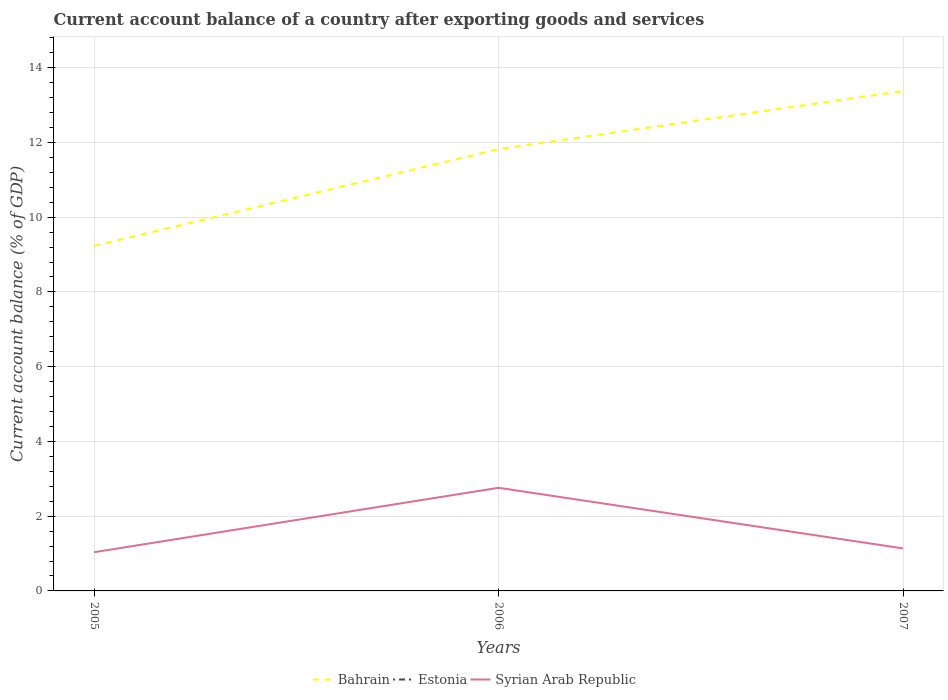Does the line corresponding to Syrian Arab Republic intersect with the line corresponding to Estonia?
Offer a very short reply. No. Is the number of lines equal to the number of legend labels?
Your response must be concise. No. Across all years, what is the maximum account balance in Bahrain?
Give a very brief answer. 9.23. What is the total account balance in Syrian Arab Republic in the graph?
Provide a succinct answer. -0.1. What is the difference between the highest and the second highest account balance in Bahrain?
Provide a succinct answer. 4.14. How many lines are there?
Give a very brief answer. 2. Are the values on the major ticks of Y-axis written in scientific E-notation?
Offer a terse response. No. Does the graph contain any zero values?
Offer a very short reply. Yes. Does the graph contain grids?
Offer a very short reply. Yes. Where does the legend appear in the graph?
Ensure brevity in your answer.  Bottom center. How many legend labels are there?
Your response must be concise. 3. How are the legend labels stacked?
Provide a succinct answer. Horizontal. What is the title of the graph?
Offer a terse response. Current account balance of a country after exporting goods and services. Does "Europe(all income levels)" appear as one of the legend labels in the graph?
Keep it short and to the point. No. What is the label or title of the Y-axis?
Provide a short and direct response. Current account balance (% of GDP). What is the Current account balance (% of GDP) in Bahrain in 2005?
Ensure brevity in your answer.  9.23. What is the Current account balance (% of GDP) in Estonia in 2005?
Your answer should be very brief. 0. What is the Current account balance (% of GDP) in Syrian Arab Republic in 2005?
Ensure brevity in your answer.  1.04. What is the Current account balance (% of GDP) of Bahrain in 2006?
Your answer should be compact. 11.82. What is the Current account balance (% of GDP) in Estonia in 2006?
Provide a succinct answer. 0. What is the Current account balance (% of GDP) of Syrian Arab Republic in 2006?
Ensure brevity in your answer.  2.76. What is the Current account balance (% of GDP) in Bahrain in 2007?
Your answer should be very brief. 13.38. What is the Current account balance (% of GDP) in Estonia in 2007?
Offer a terse response. 0. What is the Current account balance (% of GDP) of Syrian Arab Republic in 2007?
Offer a terse response. 1.14. Across all years, what is the maximum Current account balance (% of GDP) of Bahrain?
Keep it short and to the point. 13.38. Across all years, what is the maximum Current account balance (% of GDP) of Syrian Arab Republic?
Ensure brevity in your answer.  2.76. Across all years, what is the minimum Current account balance (% of GDP) in Bahrain?
Make the answer very short. 9.23. Across all years, what is the minimum Current account balance (% of GDP) in Syrian Arab Republic?
Offer a very short reply. 1.04. What is the total Current account balance (% of GDP) in Bahrain in the graph?
Provide a succinct answer. 34.43. What is the total Current account balance (% of GDP) of Estonia in the graph?
Give a very brief answer. 0. What is the total Current account balance (% of GDP) of Syrian Arab Republic in the graph?
Provide a succinct answer. 4.93. What is the difference between the Current account balance (% of GDP) of Bahrain in 2005 and that in 2006?
Give a very brief answer. -2.59. What is the difference between the Current account balance (% of GDP) of Syrian Arab Republic in 2005 and that in 2006?
Ensure brevity in your answer.  -1.72. What is the difference between the Current account balance (% of GDP) in Bahrain in 2005 and that in 2007?
Provide a short and direct response. -4.14. What is the difference between the Current account balance (% of GDP) of Syrian Arab Republic in 2005 and that in 2007?
Your answer should be very brief. -0.1. What is the difference between the Current account balance (% of GDP) in Bahrain in 2006 and that in 2007?
Give a very brief answer. -1.55. What is the difference between the Current account balance (% of GDP) in Syrian Arab Republic in 2006 and that in 2007?
Make the answer very short. 1.62. What is the difference between the Current account balance (% of GDP) of Bahrain in 2005 and the Current account balance (% of GDP) of Syrian Arab Republic in 2006?
Your response must be concise. 6.47. What is the difference between the Current account balance (% of GDP) in Bahrain in 2005 and the Current account balance (% of GDP) in Syrian Arab Republic in 2007?
Ensure brevity in your answer.  8.09. What is the difference between the Current account balance (% of GDP) in Bahrain in 2006 and the Current account balance (% of GDP) in Syrian Arab Republic in 2007?
Offer a very short reply. 10.68. What is the average Current account balance (% of GDP) of Bahrain per year?
Provide a succinct answer. 11.48. What is the average Current account balance (% of GDP) of Syrian Arab Republic per year?
Keep it short and to the point. 1.64. In the year 2005, what is the difference between the Current account balance (% of GDP) in Bahrain and Current account balance (% of GDP) in Syrian Arab Republic?
Provide a short and direct response. 8.2. In the year 2006, what is the difference between the Current account balance (% of GDP) in Bahrain and Current account balance (% of GDP) in Syrian Arab Republic?
Your answer should be compact. 9.06. In the year 2007, what is the difference between the Current account balance (% of GDP) of Bahrain and Current account balance (% of GDP) of Syrian Arab Republic?
Your answer should be very brief. 12.24. What is the ratio of the Current account balance (% of GDP) in Bahrain in 2005 to that in 2006?
Provide a succinct answer. 0.78. What is the ratio of the Current account balance (% of GDP) of Syrian Arab Republic in 2005 to that in 2006?
Make the answer very short. 0.38. What is the ratio of the Current account balance (% of GDP) in Bahrain in 2005 to that in 2007?
Provide a short and direct response. 0.69. What is the ratio of the Current account balance (% of GDP) of Syrian Arab Republic in 2005 to that in 2007?
Offer a terse response. 0.91. What is the ratio of the Current account balance (% of GDP) of Bahrain in 2006 to that in 2007?
Make the answer very short. 0.88. What is the ratio of the Current account balance (% of GDP) of Syrian Arab Republic in 2006 to that in 2007?
Give a very brief answer. 2.43. What is the difference between the highest and the second highest Current account balance (% of GDP) of Bahrain?
Provide a succinct answer. 1.55. What is the difference between the highest and the second highest Current account balance (% of GDP) in Syrian Arab Republic?
Your answer should be compact. 1.62. What is the difference between the highest and the lowest Current account balance (% of GDP) in Bahrain?
Your response must be concise. 4.14. What is the difference between the highest and the lowest Current account balance (% of GDP) of Syrian Arab Republic?
Offer a terse response. 1.72. 